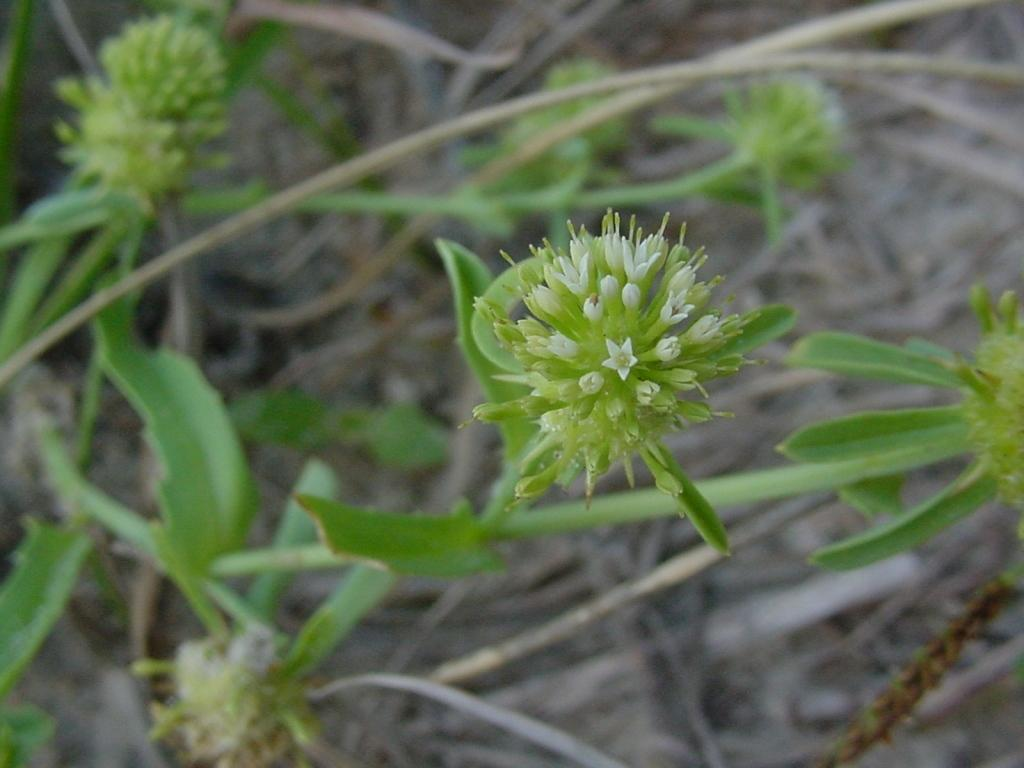What type of flower is present in the image? There is a green color buttercup in the image. What other plant elements can be seen in the image? There are green color leaves in the image. What type of plantation is visible in the image? There is no plantation present in the image; it only features a buttercup and leaves. What kind of bulb can be seen in the image? There is no bulb present in the image; it only features a buttercup and leaves. 